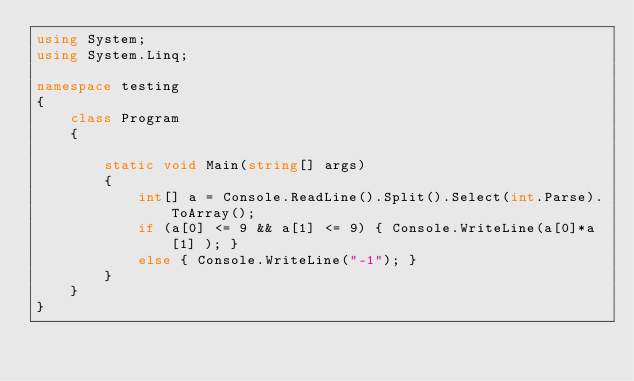<code> <loc_0><loc_0><loc_500><loc_500><_C#_>using System;
using System.Linq;

namespace testing
{
    class Program
    {

        static void Main(string[] args)
        {
            int[] a = Console.ReadLine().Split().Select(int.Parse).ToArray();
            if (a[0] <= 9 && a[1] <= 9) { Console.WriteLine(a[0]*a[1] ); }
            else { Console.WriteLine("-1"); }
        }
    }
}
</code> 